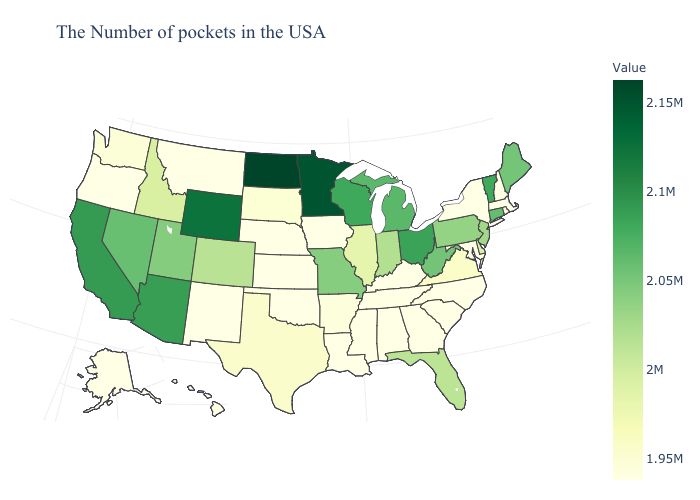Is the legend a continuous bar?
Quick response, please. Yes. Does Connecticut have the lowest value in the Northeast?
Write a very short answer. No. Does Massachusetts have the lowest value in the USA?
Give a very brief answer. Yes. Among the states that border Massachusetts , does Vermont have the highest value?
Answer briefly. Yes. Which states have the highest value in the USA?
Concise answer only. North Dakota. Does New Hampshire have the highest value in the USA?
Concise answer only. No. Among the states that border California , which have the lowest value?
Short answer required. Oregon. Is the legend a continuous bar?
Quick response, please. Yes. 